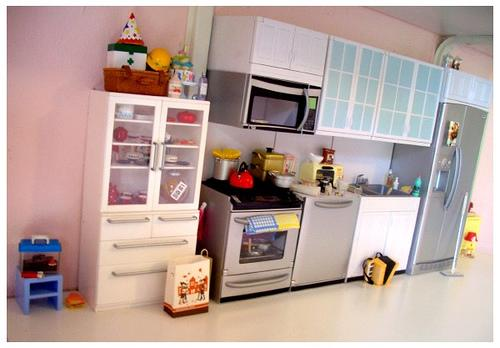What type of people obviously live here?

Choices:
A) children
B) middle aged
C) elderly
D) infirm children 